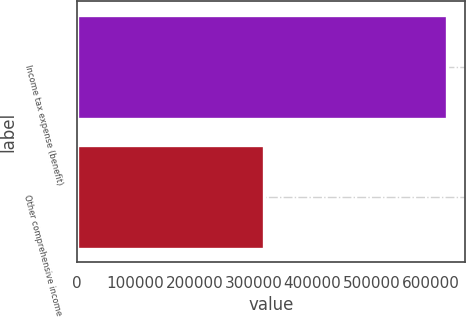Convert chart. <chart><loc_0><loc_0><loc_500><loc_500><bar_chart><fcel>Income tax expense (benefit)<fcel>Other comprehensive income<nl><fcel>627615<fcel>318475<nl></chart> 